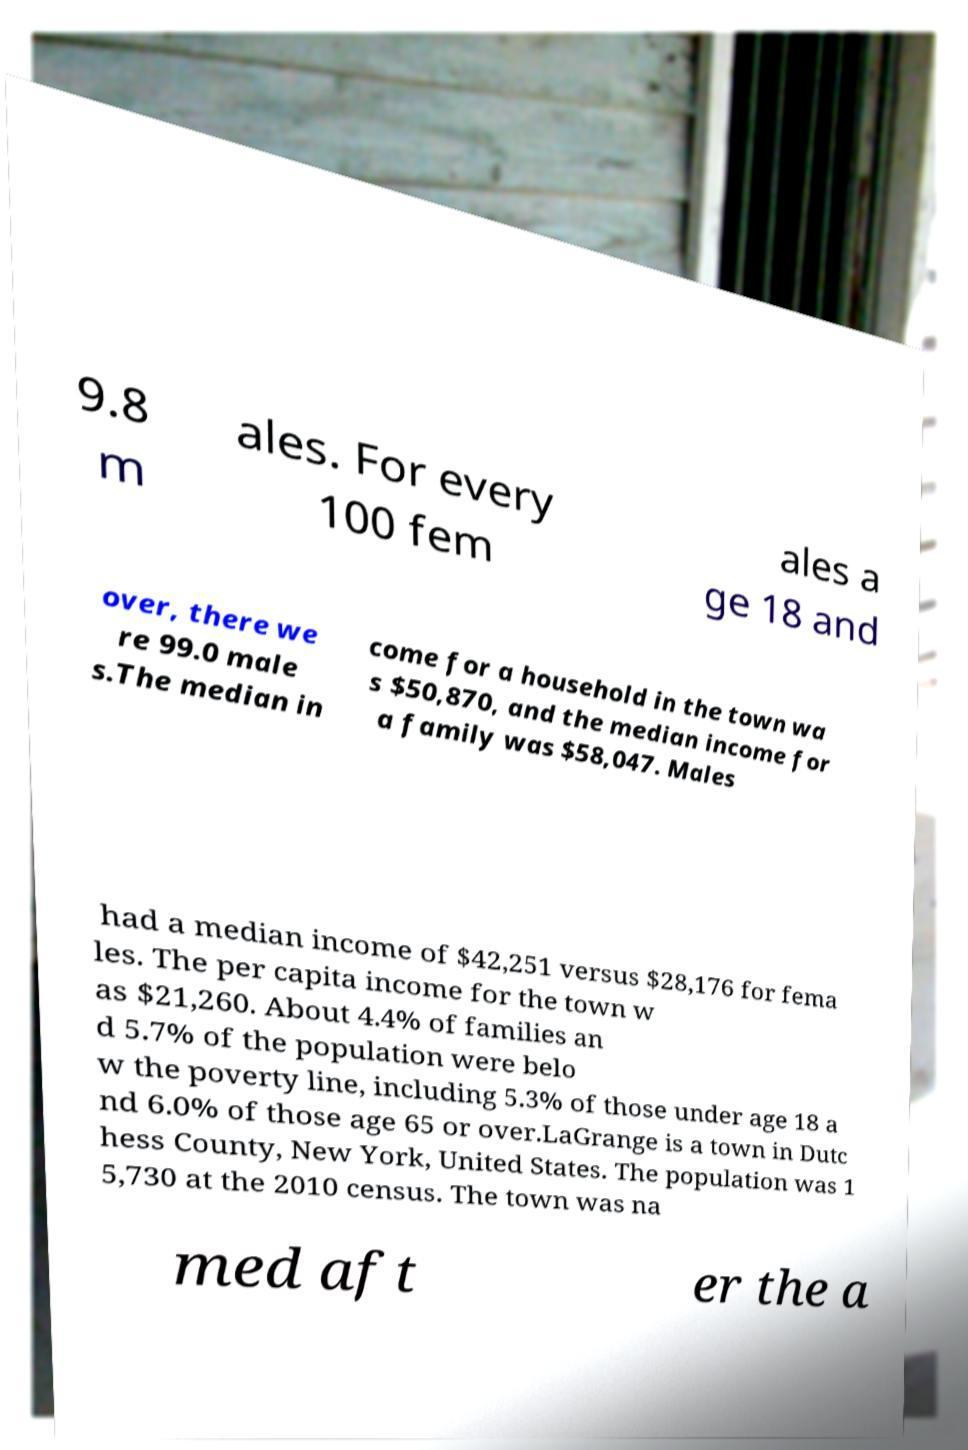Can you accurately transcribe the text from the provided image for me? 9.8 m ales. For every 100 fem ales a ge 18 and over, there we re 99.0 male s.The median in come for a household in the town wa s $50,870, and the median income for a family was $58,047. Males had a median income of $42,251 versus $28,176 for fema les. The per capita income for the town w as $21,260. About 4.4% of families an d 5.7% of the population were belo w the poverty line, including 5.3% of those under age 18 a nd 6.0% of those age 65 or over.LaGrange is a town in Dutc hess County, New York, United States. The population was 1 5,730 at the 2010 census. The town was na med aft er the a 